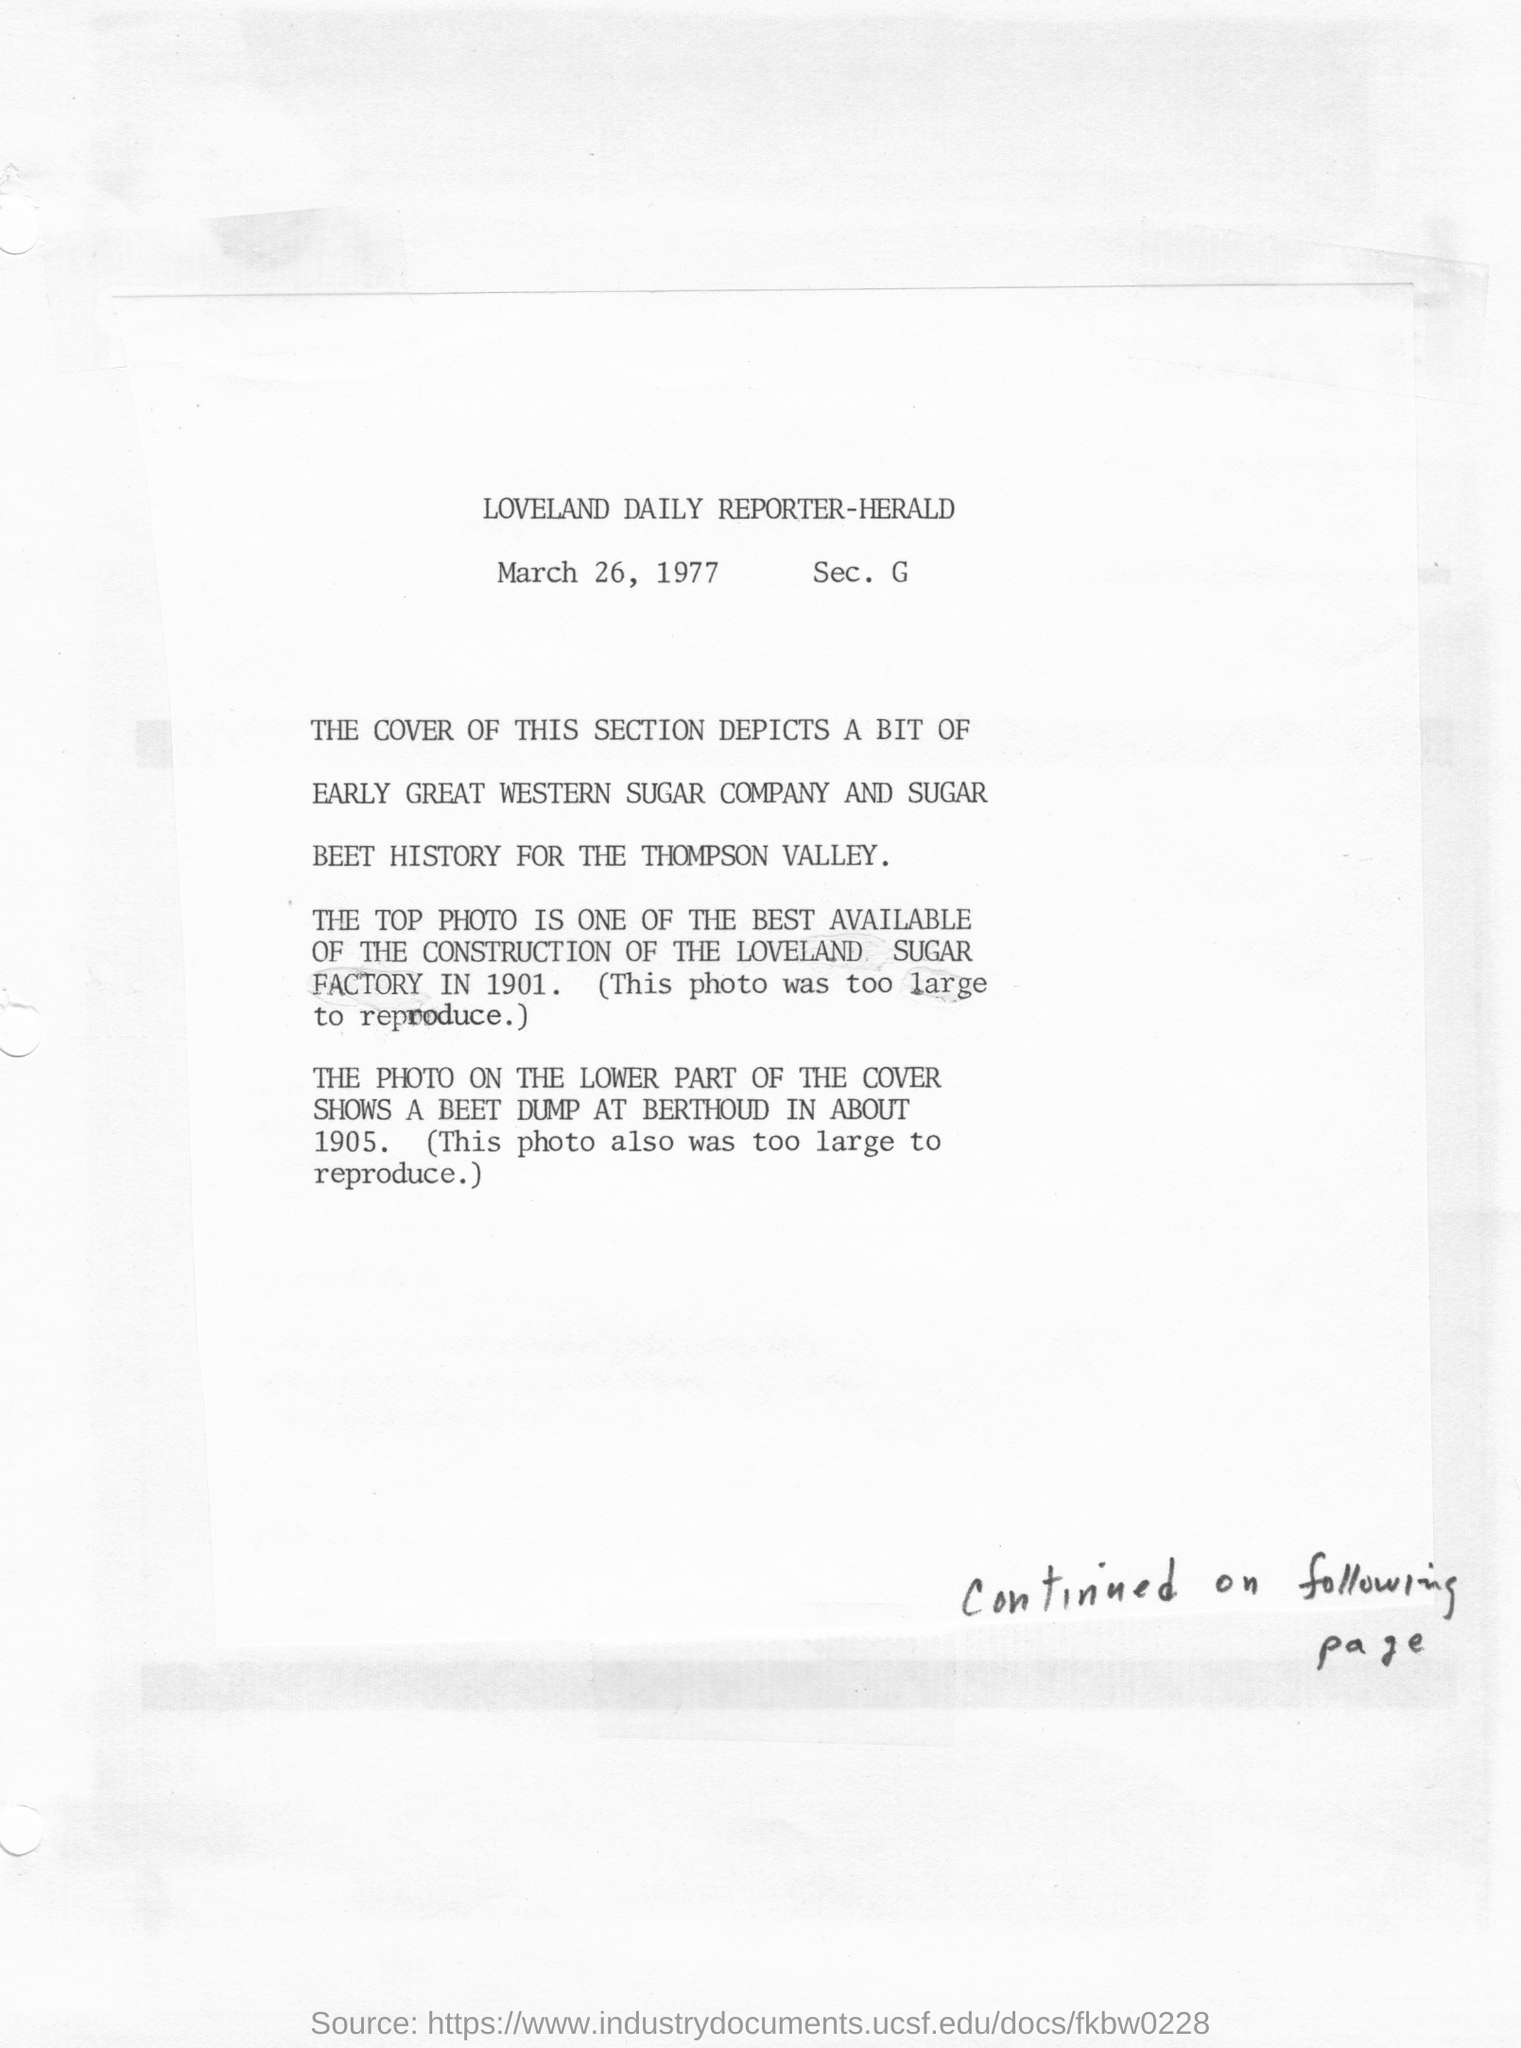What is the date on the article?
Make the answer very short. March 26, 1977. 